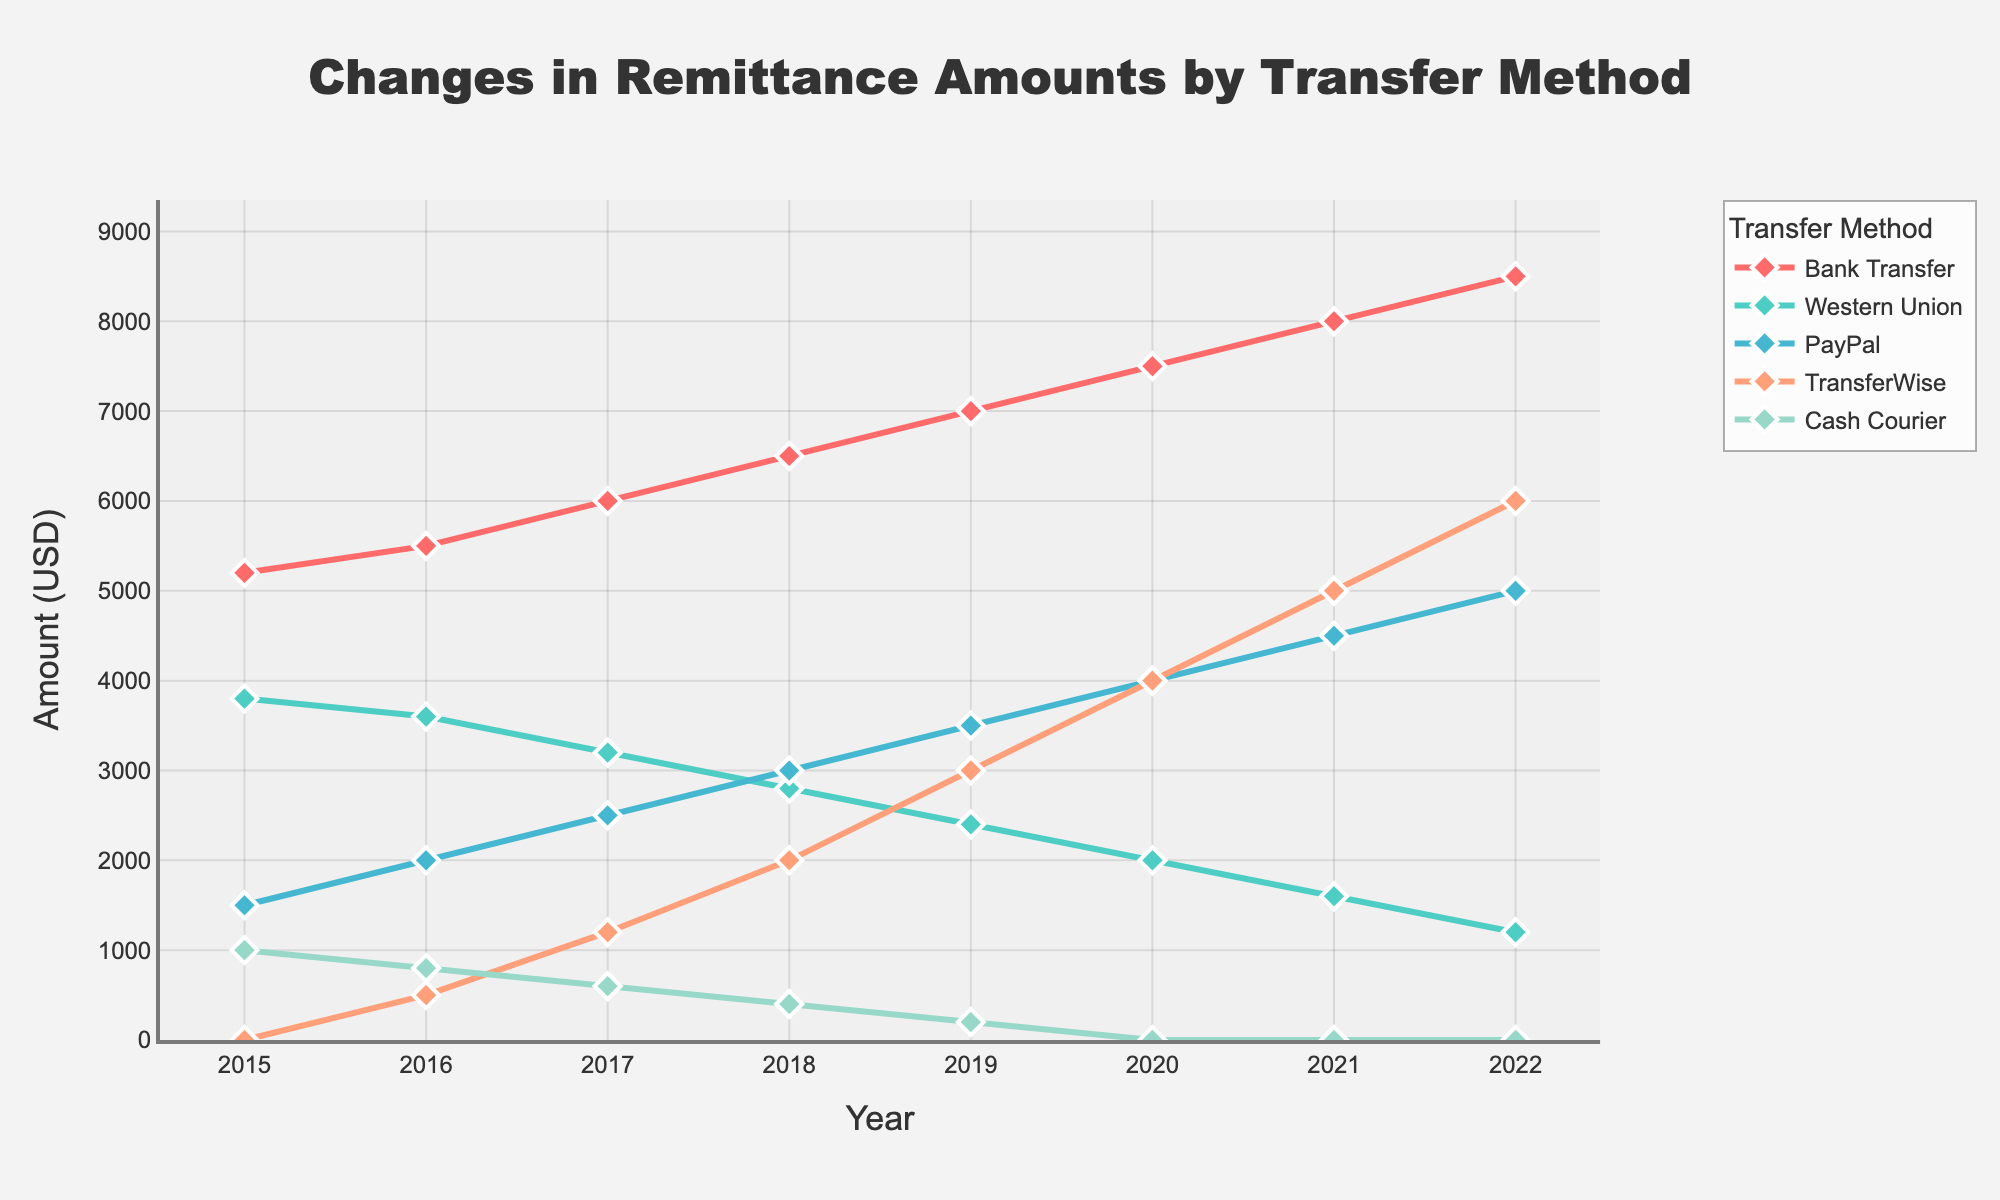Which transfer method shows the highest remittance amount in the year 2022? By observing the plot, we can see which transfer method has the highest value for 2022. 'Bank Transfer' line reaches the highest point in 2022.
Answer: Bank Transfer Between which years did the remittance amount for 'Western Union' show the largest decline? By following the 'Western Union' line, we see the sharpest drop between 2021 and 2022.
Answer: Between 2021 and 2022 What is the combined remittance amount sent through 'PayPal' in 2017 and 'TransferWise' in 2021? We need to add the values of 'PayPal' in 2017 and 'TransferWise' in 2021 from the plot. The values are PayPal (2500) and TransferWise (5000).
Answer: 7500 Which year did 'Bank Transfer' surpass $6000 in remittance amounts? By looking at the 'Bank Transfer' trendline, it first crosses the $6000 mark in the year 2017.
Answer: 2017 How does 'Cash Courier' remittance change over the given years? We can observe the 'Cash Courier' line in the plot. It starts high at 1000 in 2015 and gradually decreases to 0 by 2020 and remains at 0.
Answer: Gradually decreases Which transfer method had the remittance amount crossing 'Bank Transfer' in the year 2020? Viewing the plot for the year 2020, 'TransferWise' clearly crosses the 'Bank Transfer' amount.
Answer: TransferWise What is the total remittance sent through 'Western Union' over the years 2015 to 2022? Adding up the annual remittance amounts for 'Western Union': 3800 + 3600 + 3200 + 2800 + 2400 + 2000 + 1600 + 1200 = 20600.
Answer: 20600 In 2019, which transfer method shows a remittance amount lower than 'Cash Courier'? Looking at the remittance amounts in 2019, 'Western Union' (2400) and 'Cash Courier' (200) show that 'Cash Courier' is lower.
Answer: Cash Courier What is the difference in remittance amounts between 'PayPal' and 'Western Union' in 2015? We subtract the 2015 value of 'Western Union' from 'PayPal'. PayPal (1500) - Western Union (3800) = -2300.
Answer: -2300 Which transfer method shows a consistent increase in remittance amounts every year? By observing the trends from 2015 to 2022, 'TransferWise' consistently increases every year.
Answer: TransferWise 